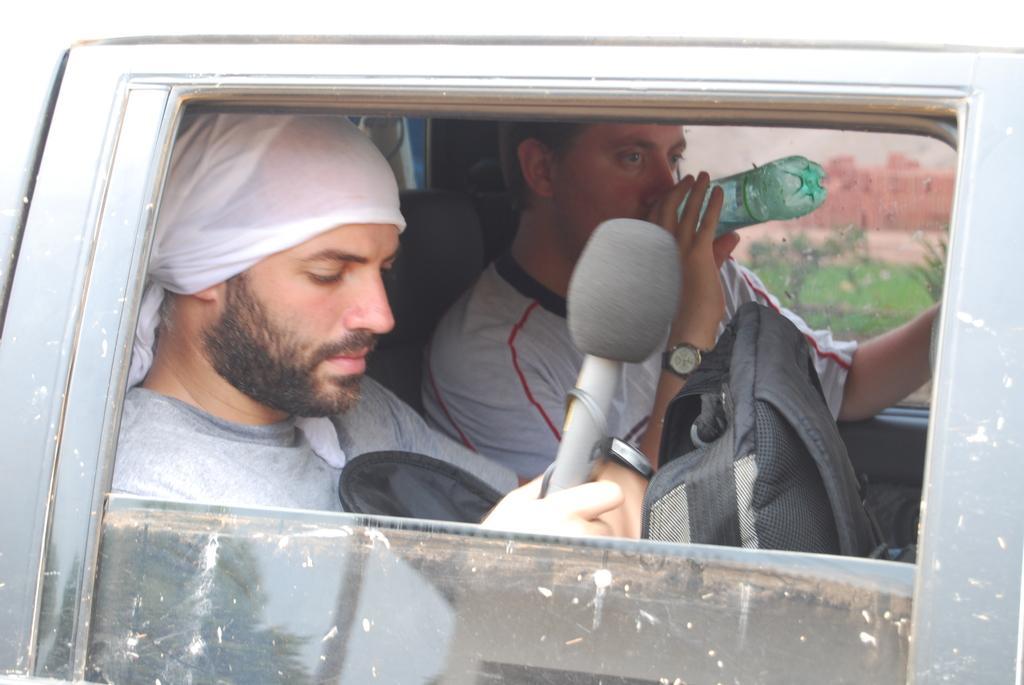Could you give a brief overview of what you see in this image? In this image I can see two people inside the vehicle. I can see one person with the bag and mic and an another person with the bottle. In the background I can see the plants and the wall. 